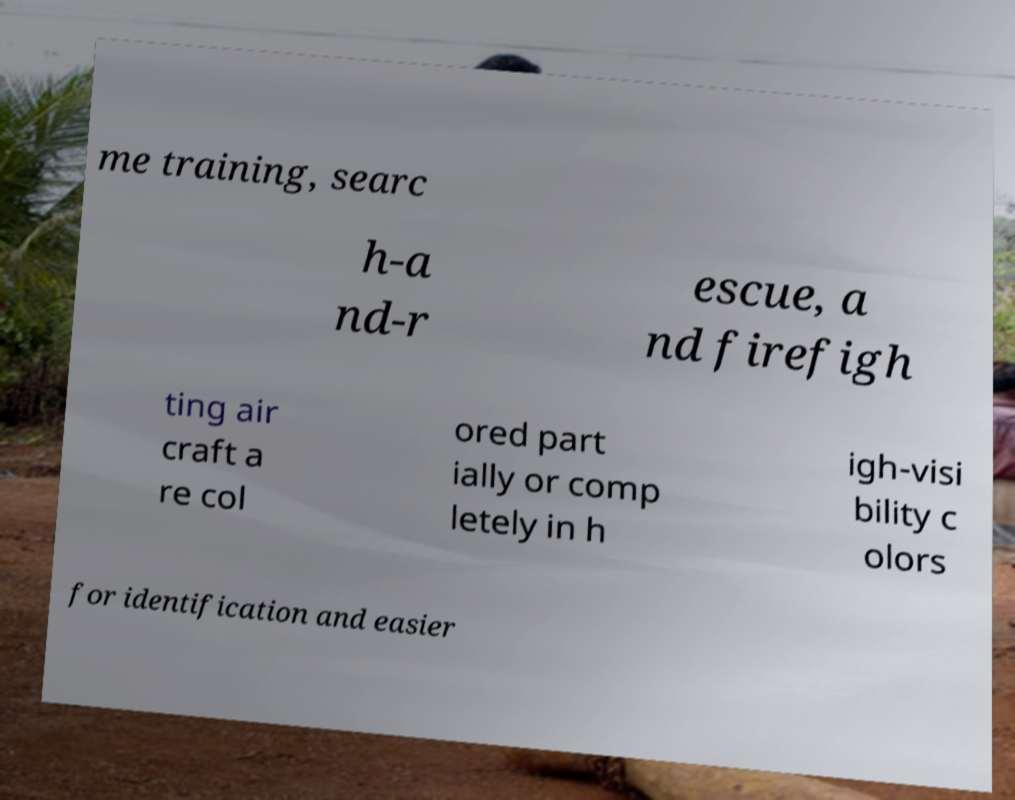Could you extract and type out the text from this image? me training, searc h-a nd-r escue, a nd firefigh ting air craft a re col ored part ially or comp letely in h igh-visi bility c olors for identification and easier 